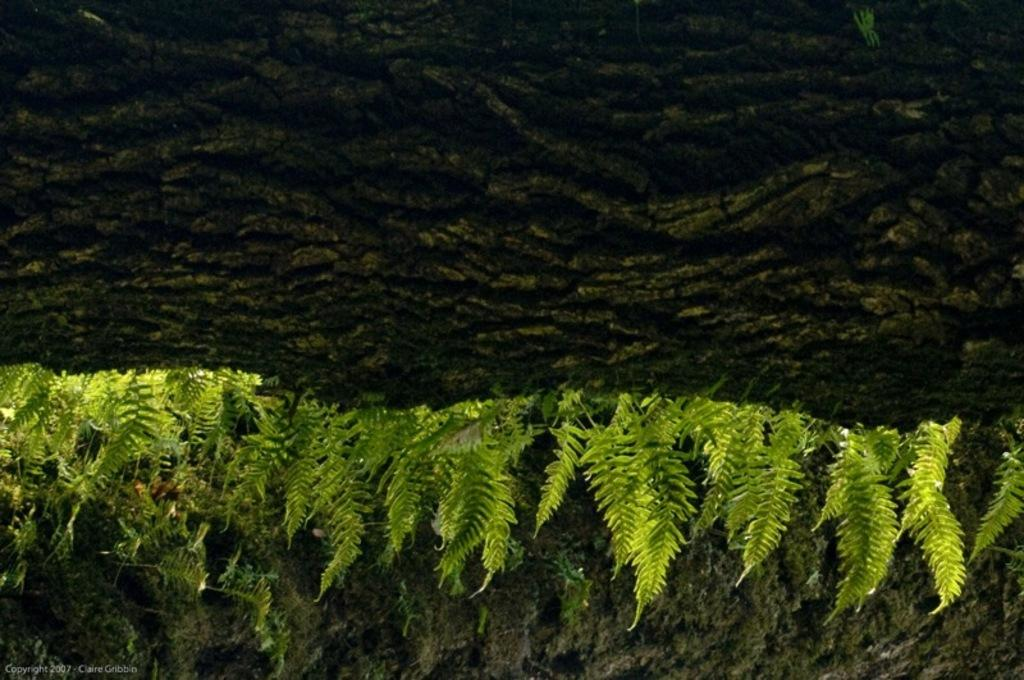What type of vegetation is present in the image? There are green plants in the image. What can be seen beneath the plants in the image? The ground is visible in the image. What type of grain is being harvested by the cats in the image? A: There are no cats or grain present in the image; it features green plants and visible ground. 